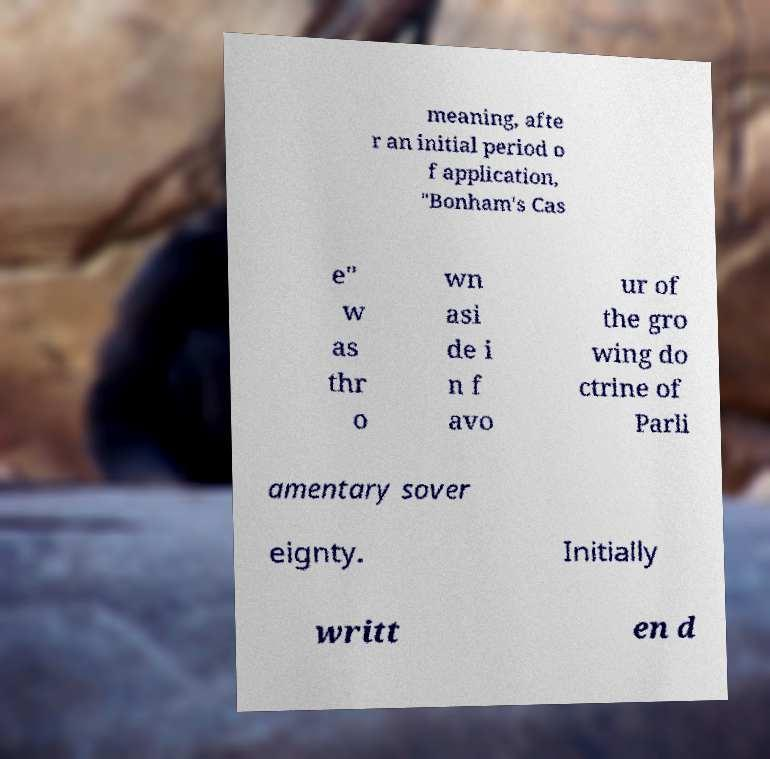Please identify and transcribe the text found in this image. meaning, afte r an initial period o f application, "Bonham's Cas e" w as thr o wn asi de i n f avo ur of the gro wing do ctrine of Parli amentary sover eignty. Initially writt en d 